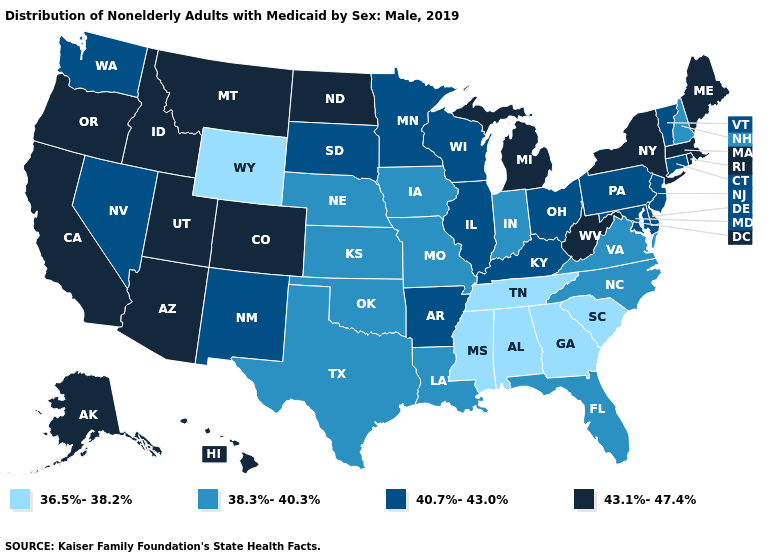Does West Virginia have the highest value in the USA?
Give a very brief answer. Yes. Which states have the lowest value in the USA?
Be succinct. Alabama, Georgia, Mississippi, South Carolina, Tennessee, Wyoming. Does Iowa have the same value as North Carolina?
Give a very brief answer. Yes. Name the states that have a value in the range 43.1%-47.4%?
Give a very brief answer. Alaska, Arizona, California, Colorado, Hawaii, Idaho, Maine, Massachusetts, Michigan, Montana, New York, North Dakota, Oregon, Rhode Island, Utah, West Virginia. What is the value of North Carolina?
Short answer required. 38.3%-40.3%. Name the states that have a value in the range 43.1%-47.4%?
Be succinct. Alaska, Arizona, California, Colorado, Hawaii, Idaho, Maine, Massachusetts, Michigan, Montana, New York, North Dakota, Oregon, Rhode Island, Utah, West Virginia. Among the states that border South Carolina , does Georgia have the highest value?
Concise answer only. No. What is the lowest value in the USA?
Short answer required. 36.5%-38.2%. What is the lowest value in the USA?
Give a very brief answer. 36.5%-38.2%. Which states hav the highest value in the MidWest?
Short answer required. Michigan, North Dakota. Does South Carolina have a higher value than Alabama?
Concise answer only. No. What is the value of Nevada?
Keep it brief. 40.7%-43.0%. Which states have the lowest value in the MidWest?
Keep it brief. Indiana, Iowa, Kansas, Missouri, Nebraska. Which states have the lowest value in the South?
Be succinct. Alabama, Georgia, Mississippi, South Carolina, Tennessee. 